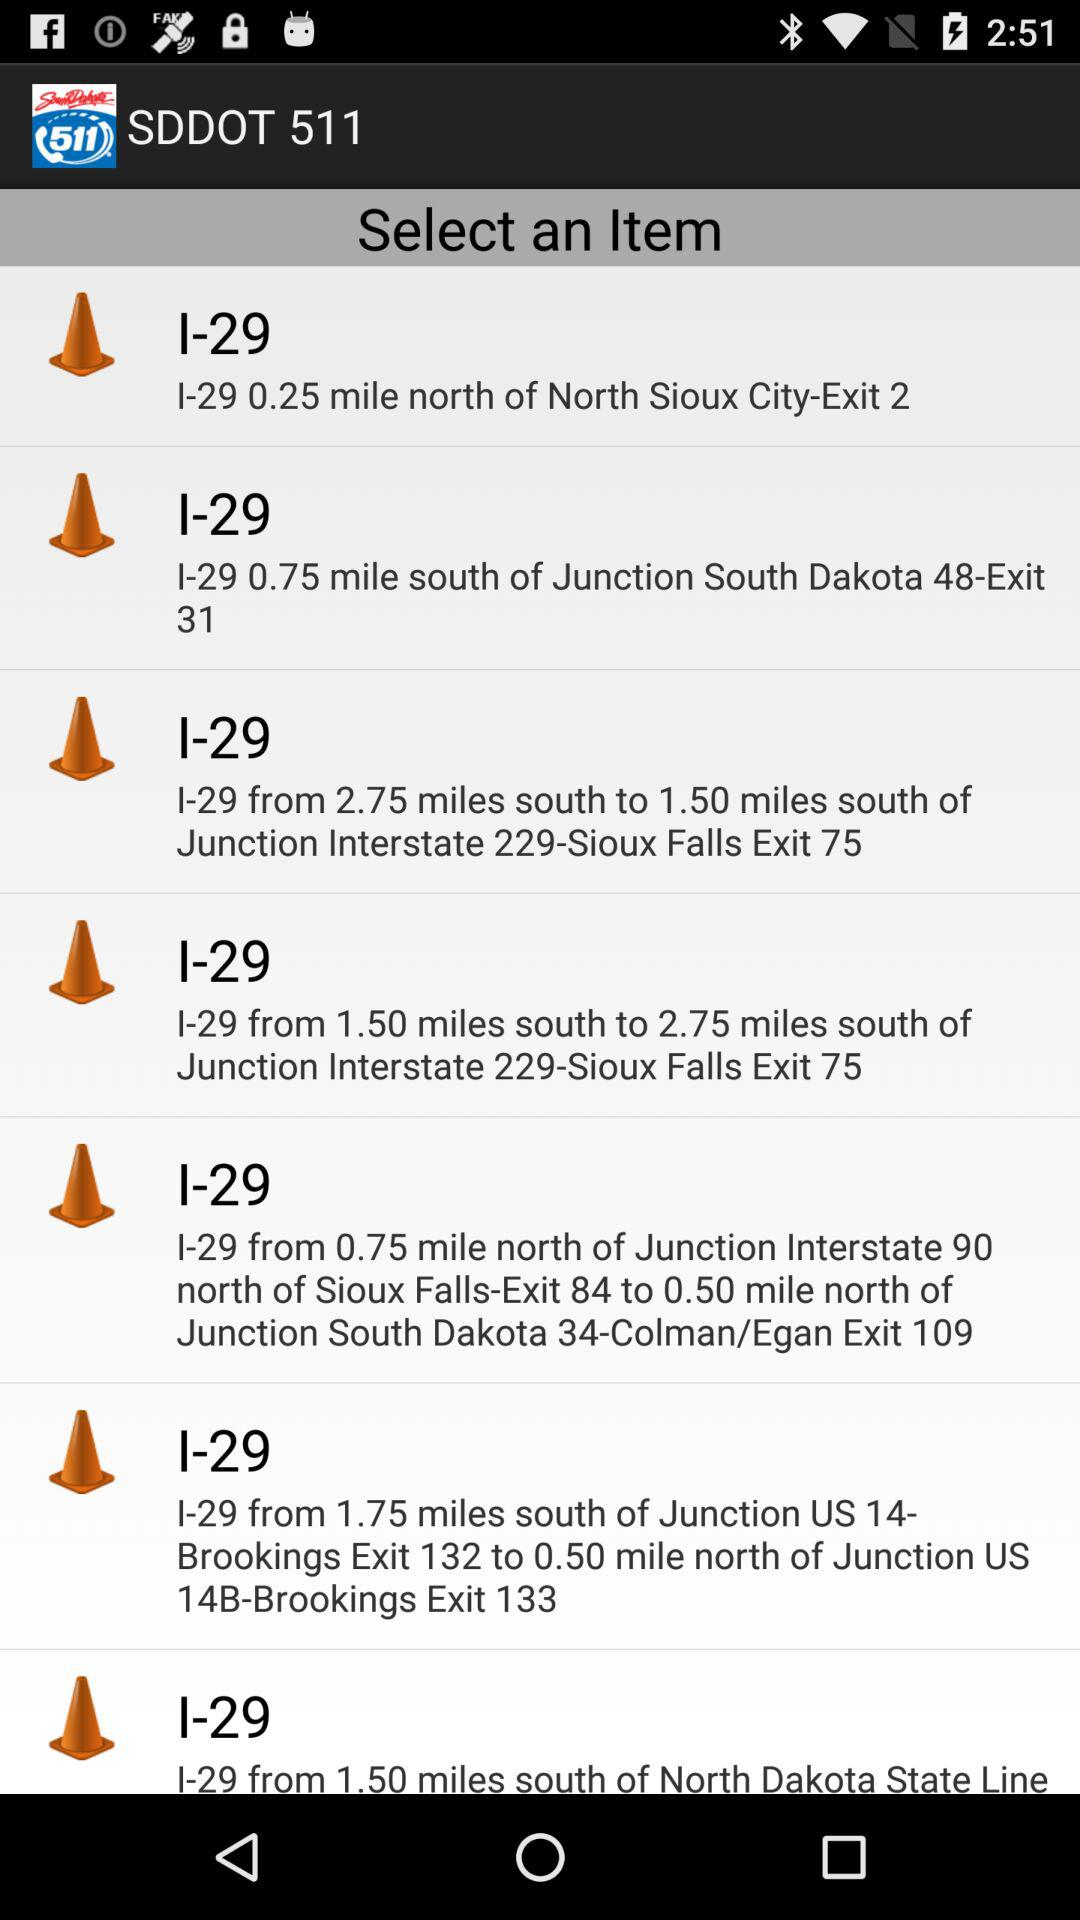Which item is selected?
When the provided information is insufficient, respond with <no answer>. <no answer> 